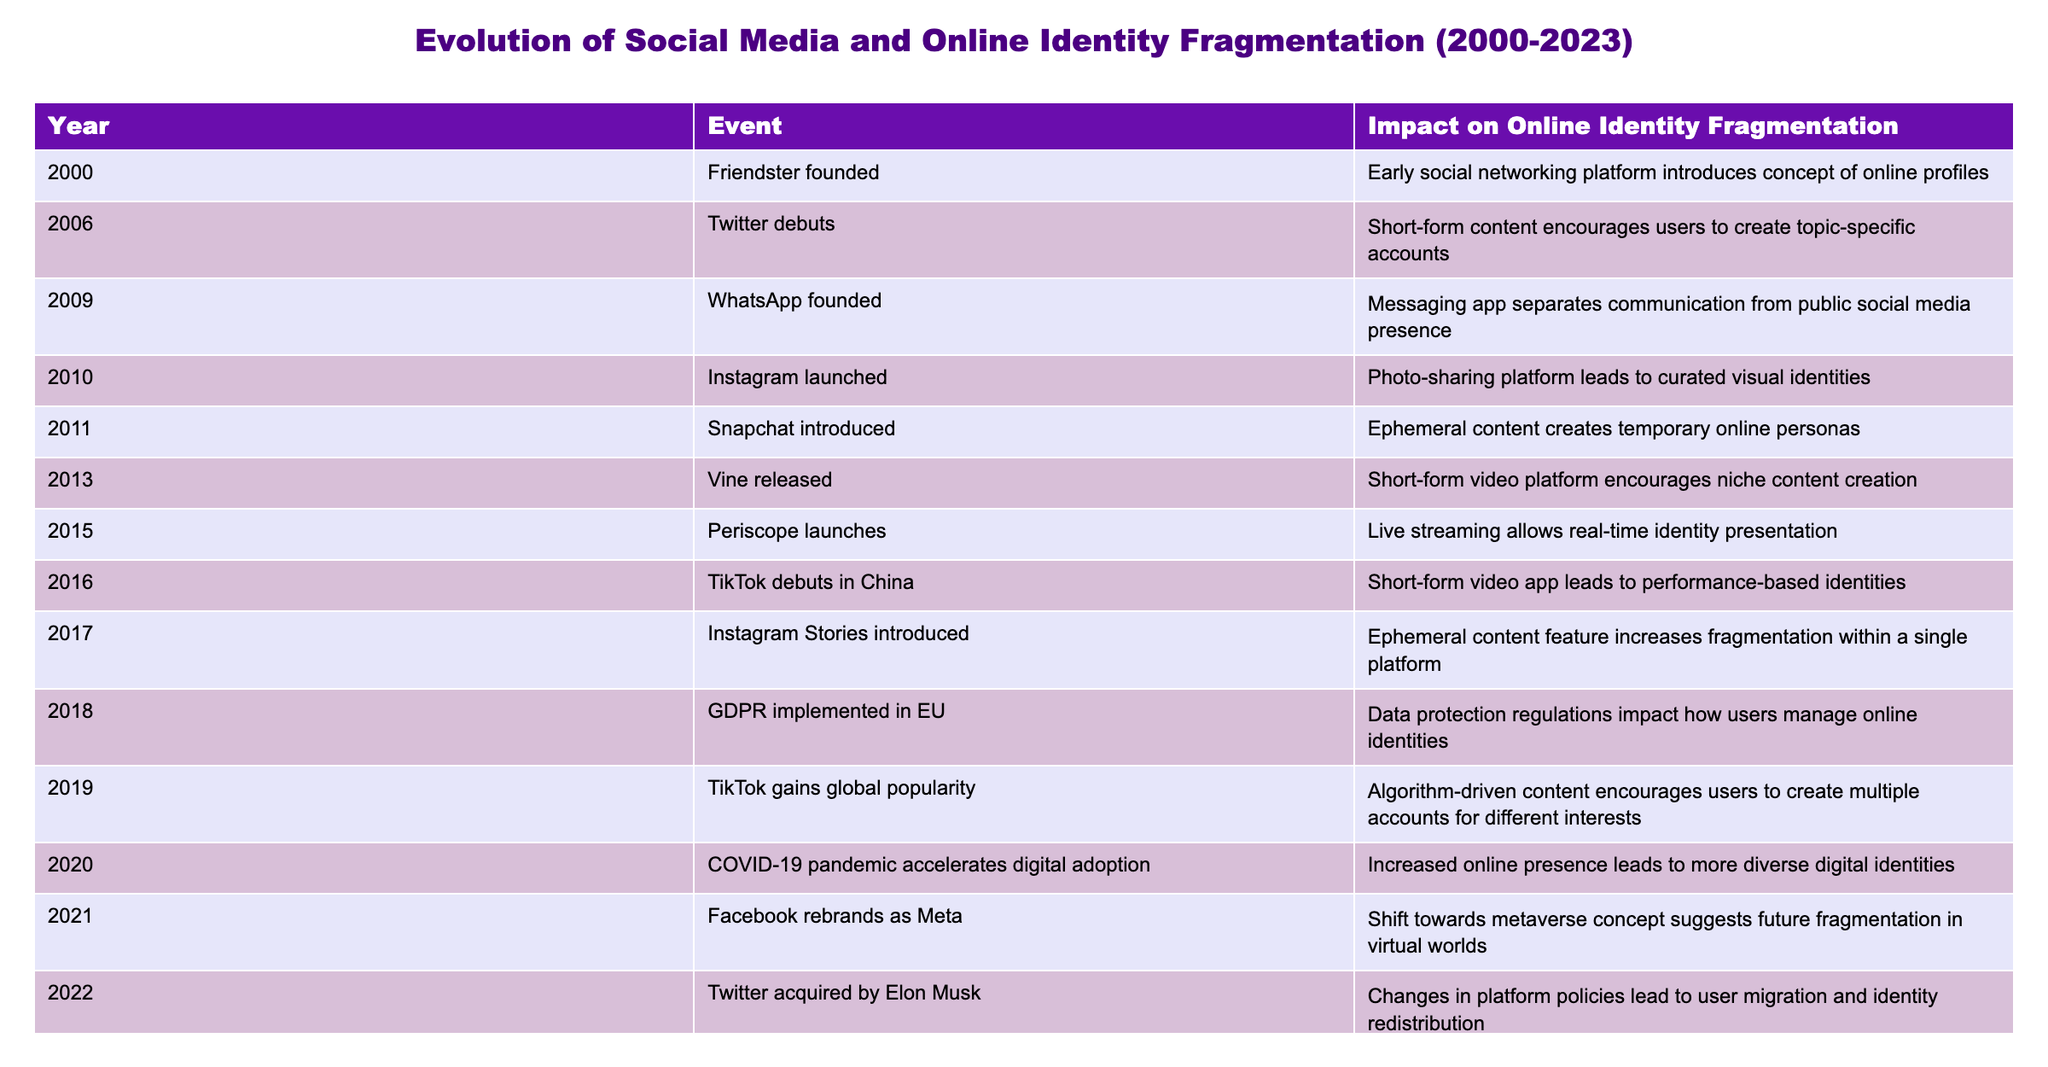What year was Friendster founded? Friendster is listed as the first event in the table, with the year specified as 2000.
Answer: 2000 How many social media platforms were launched between 2000 and 2010? The table lists Friendster in 2000, Twitter in 2006, WhatsApp in 2009, and Instagram in 2010. This totals to four platforms: Friendster, Twitter, WhatsApp, and Instagram.
Answer: 4 What was the impact of TikTok's global popularity in 2019? The impact mentioned for TikTok's global popularity in 2019 is that it encourages users to create multiple accounts for different interests, indicating increased fragmentation of identities.
Answer: Users create multiple accounts for interests Did the GDPR implementation in 2018 affect online identity management? Yes, the table notes that GDPR implemented in the EU impacts how users manage online identities, suggesting it had significant effects on identity management practices.
Answer: Yes Compare the impacts on online identity fragmentation of Instagram and Snapchat. Instagram, launched in 2010, leads to curated visual identities, while Snapchat, introduced in 2011, creates temporary online personas with its ephemeral content feature. This indicates that Instagram promotes a more permanent and curated identity compared to Snapchat's temporary nature.
Answer: Instagram promotes curated identities; Snapchat creates temporary personas What was the trend regarding identity fragmentation from 2020 to 2023? In 2020, the COVID-19 pandemic accelerated digital adoption, leading to more diverse digital identities. By 2023, the prevalence of AI-generated content blurred the lines between authentic and artificial identities. This indicates a progression from increased diversity to confusion in identity authenticity.
Answer: From increased diversity to blurred authenticity lines Was there any significant event affecting social media user migration in 2022? Yes, the acquisition of Twitter by Elon Musk led to changes in platform policies, which in turn caused user migration and identity redistribution on the platform.
Answer: Yes What is the average year when platforms promoting ephemeral content were launched? Ephemeral content platforms are Snapchat (2011), Instagram Stories (2017), and TikTok (2016, for its specific features). The average year is calculated as (2011 + 2017 + 2016) / 3 = 2014.67, which rounds to 2015.
Answer: 2015 